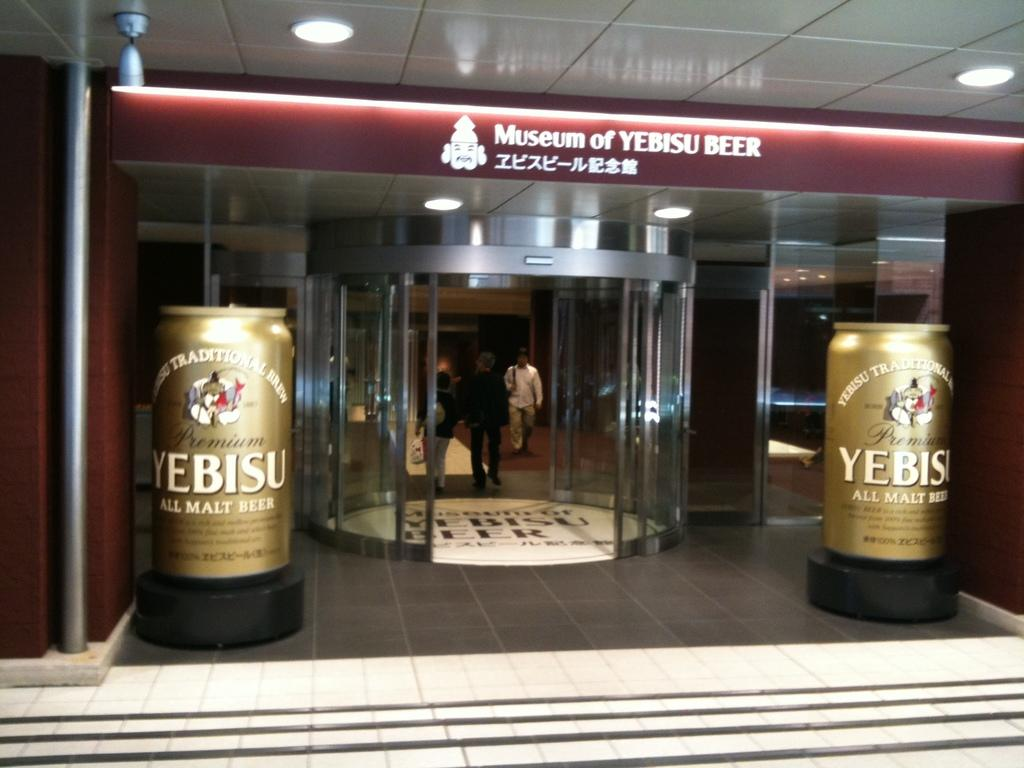What can be found on the surface in the image? There are twins on the surface, along with a road and glass. What else is present on the surface? There is a sticker on the surface. What can be seen in the background of the image? There are people in the background. What is visible at the top of the image? Lights are visible at the top of the image. What type of lipstick is the ship using in the image? There is no ship or lipstick present in the image. On which side of the surface are the twins located? The image does not specify the side of the surface where the twins are located. 